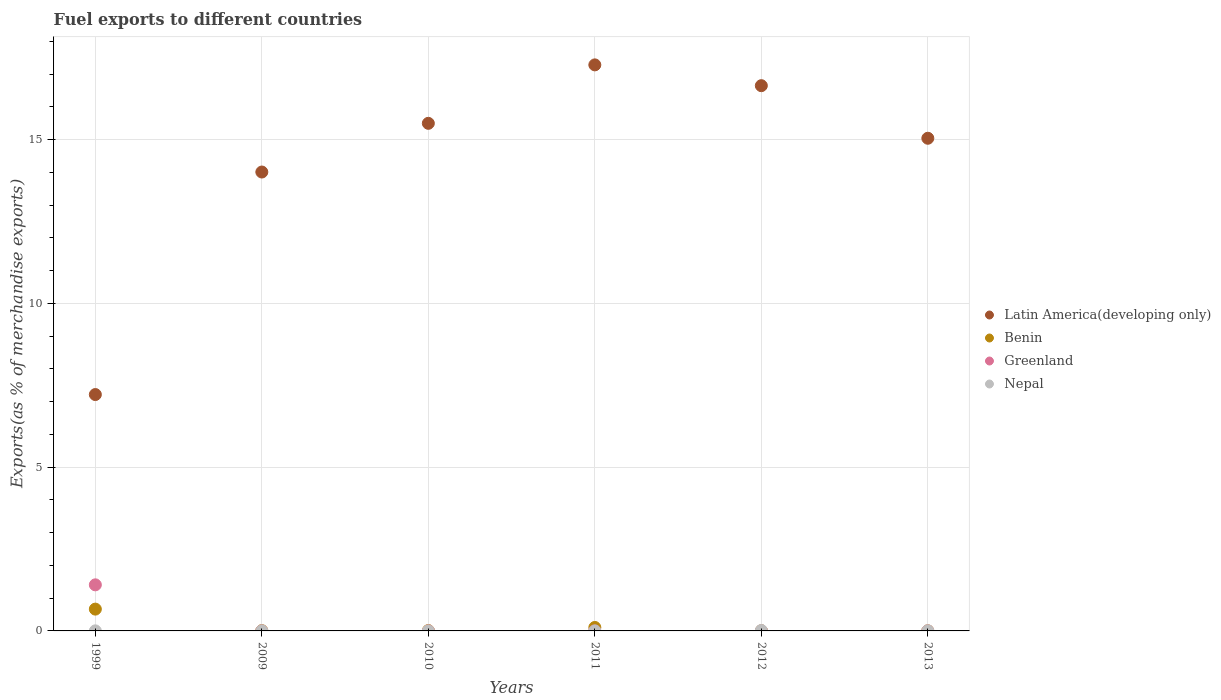Is the number of dotlines equal to the number of legend labels?
Keep it short and to the point. Yes. What is the percentage of exports to different countries in Benin in 1999?
Your answer should be very brief. 0.67. Across all years, what is the maximum percentage of exports to different countries in Nepal?
Offer a very short reply. 0.01. Across all years, what is the minimum percentage of exports to different countries in Nepal?
Give a very brief answer. 5.17830048737702e-6. In which year was the percentage of exports to different countries in Greenland minimum?
Keep it short and to the point. 2009. What is the total percentage of exports to different countries in Nepal in the graph?
Offer a terse response. 0.02. What is the difference between the percentage of exports to different countries in Greenland in 2009 and that in 2013?
Make the answer very short. -1.022851783200839e-5. What is the difference between the percentage of exports to different countries in Greenland in 2011 and the percentage of exports to different countries in Benin in 1999?
Your answer should be very brief. -0.67. What is the average percentage of exports to different countries in Benin per year?
Offer a terse response. 0.13. In the year 2009, what is the difference between the percentage of exports to different countries in Latin America(developing only) and percentage of exports to different countries in Benin?
Keep it short and to the point. 14. In how many years, is the percentage of exports to different countries in Latin America(developing only) greater than 7 %?
Offer a very short reply. 6. What is the ratio of the percentage of exports to different countries in Greenland in 2010 to that in 2013?
Provide a short and direct response. 6.64. Is the difference between the percentage of exports to different countries in Latin America(developing only) in 1999 and 2011 greater than the difference between the percentage of exports to different countries in Benin in 1999 and 2011?
Provide a short and direct response. No. What is the difference between the highest and the second highest percentage of exports to different countries in Greenland?
Provide a succinct answer. 1.41. What is the difference between the highest and the lowest percentage of exports to different countries in Greenland?
Give a very brief answer. 1.41. Is the sum of the percentage of exports to different countries in Nepal in 2009 and 2011 greater than the maximum percentage of exports to different countries in Benin across all years?
Offer a terse response. No. Is it the case that in every year, the sum of the percentage of exports to different countries in Greenland and percentage of exports to different countries in Latin America(developing only)  is greater than the sum of percentage of exports to different countries in Nepal and percentage of exports to different countries in Benin?
Your answer should be compact. Yes. Does the percentage of exports to different countries in Benin monotonically increase over the years?
Your response must be concise. No. What is the title of the graph?
Give a very brief answer. Fuel exports to different countries. Does "Brunei Darussalam" appear as one of the legend labels in the graph?
Your answer should be compact. No. What is the label or title of the X-axis?
Ensure brevity in your answer.  Years. What is the label or title of the Y-axis?
Provide a succinct answer. Exports(as % of merchandise exports). What is the Exports(as % of merchandise exports) in Latin America(developing only) in 1999?
Ensure brevity in your answer.  7.22. What is the Exports(as % of merchandise exports) of Benin in 1999?
Provide a succinct answer. 0.67. What is the Exports(as % of merchandise exports) in Greenland in 1999?
Your answer should be compact. 1.41. What is the Exports(as % of merchandise exports) in Nepal in 1999?
Ensure brevity in your answer.  0. What is the Exports(as % of merchandise exports) in Latin America(developing only) in 2009?
Make the answer very short. 14.01. What is the Exports(as % of merchandise exports) of Benin in 2009?
Provide a short and direct response. 0.01. What is the Exports(as % of merchandise exports) of Greenland in 2009?
Ensure brevity in your answer.  6.028633814473571e-5. What is the Exports(as % of merchandise exports) of Nepal in 2009?
Offer a very short reply. 0. What is the Exports(as % of merchandise exports) of Latin America(developing only) in 2010?
Offer a terse response. 15.5. What is the Exports(as % of merchandise exports) in Benin in 2010?
Give a very brief answer. 0.01. What is the Exports(as % of merchandise exports) in Greenland in 2010?
Offer a very short reply. 0. What is the Exports(as % of merchandise exports) in Nepal in 2010?
Offer a terse response. 4.5184108995034e-5. What is the Exports(as % of merchandise exports) in Latin America(developing only) in 2011?
Ensure brevity in your answer.  17.28. What is the Exports(as % of merchandise exports) in Benin in 2011?
Make the answer very short. 0.11. What is the Exports(as % of merchandise exports) of Greenland in 2011?
Offer a very short reply. 0. What is the Exports(as % of merchandise exports) in Nepal in 2011?
Give a very brief answer. 5.17830048737702e-6. What is the Exports(as % of merchandise exports) in Latin America(developing only) in 2012?
Your answer should be compact. 16.65. What is the Exports(as % of merchandise exports) of Benin in 2012?
Offer a terse response. 0.01. What is the Exports(as % of merchandise exports) in Greenland in 2012?
Give a very brief answer. 0. What is the Exports(as % of merchandise exports) of Nepal in 2012?
Give a very brief answer. 0.01. What is the Exports(as % of merchandise exports) in Latin America(developing only) in 2013?
Your response must be concise. 15.04. What is the Exports(as % of merchandise exports) of Benin in 2013?
Your answer should be very brief. 0. What is the Exports(as % of merchandise exports) in Greenland in 2013?
Your answer should be very brief. 7.05148559767441e-5. What is the Exports(as % of merchandise exports) in Nepal in 2013?
Make the answer very short. 0. Across all years, what is the maximum Exports(as % of merchandise exports) in Latin America(developing only)?
Ensure brevity in your answer.  17.28. Across all years, what is the maximum Exports(as % of merchandise exports) in Benin?
Your response must be concise. 0.67. Across all years, what is the maximum Exports(as % of merchandise exports) in Greenland?
Ensure brevity in your answer.  1.41. Across all years, what is the maximum Exports(as % of merchandise exports) in Nepal?
Provide a succinct answer. 0.01. Across all years, what is the minimum Exports(as % of merchandise exports) in Latin America(developing only)?
Your response must be concise. 7.22. Across all years, what is the minimum Exports(as % of merchandise exports) in Benin?
Your response must be concise. 0. Across all years, what is the minimum Exports(as % of merchandise exports) in Greenland?
Ensure brevity in your answer.  6.028633814473571e-5. Across all years, what is the minimum Exports(as % of merchandise exports) in Nepal?
Ensure brevity in your answer.  5.17830048737702e-6. What is the total Exports(as % of merchandise exports) of Latin America(developing only) in the graph?
Make the answer very short. 85.71. What is the total Exports(as % of merchandise exports) of Benin in the graph?
Offer a terse response. 0.8. What is the total Exports(as % of merchandise exports) of Greenland in the graph?
Your answer should be compact. 1.41. What is the total Exports(as % of merchandise exports) of Nepal in the graph?
Ensure brevity in your answer.  0.02. What is the difference between the Exports(as % of merchandise exports) in Latin America(developing only) in 1999 and that in 2009?
Your answer should be compact. -6.79. What is the difference between the Exports(as % of merchandise exports) of Benin in 1999 and that in 2009?
Offer a terse response. 0.66. What is the difference between the Exports(as % of merchandise exports) of Greenland in 1999 and that in 2009?
Ensure brevity in your answer.  1.41. What is the difference between the Exports(as % of merchandise exports) of Latin America(developing only) in 1999 and that in 2010?
Ensure brevity in your answer.  -8.28. What is the difference between the Exports(as % of merchandise exports) in Benin in 1999 and that in 2010?
Make the answer very short. 0.66. What is the difference between the Exports(as % of merchandise exports) in Greenland in 1999 and that in 2010?
Give a very brief answer. 1.41. What is the difference between the Exports(as % of merchandise exports) of Nepal in 1999 and that in 2010?
Provide a short and direct response. 0. What is the difference between the Exports(as % of merchandise exports) in Latin America(developing only) in 1999 and that in 2011?
Offer a terse response. -10.07. What is the difference between the Exports(as % of merchandise exports) in Benin in 1999 and that in 2011?
Keep it short and to the point. 0.56. What is the difference between the Exports(as % of merchandise exports) of Greenland in 1999 and that in 2011?
Ensure brevity in your answer.  1.41. What is the difference between the Exports(as % of merchandise exports) of Nepal in 1999 and that in 2011?
Offer a very short reply. 0. What is the difference between the Exports(as % of merchandise exports) in Latin America(developing only) in 1999 and that in 2012?
Your answer should be very brief. -9.43. What is the difference between the Exports(as % of merchandise exports) in Benin in 1999 and that in 2012?
Keep it short and to the point. 0.66. What is the difference between the Exports(as % of merchandise exports) in Greenland in 1999 and that in 2012?
Your answer should be very brief. 1.41. What is the difference between the Exports(as % of merchandise exports) of Nepal in 1999 and that in 2012?
Ensure brevity in your answer.  -0.01. What is the difference between the Exports(as % of merchandise exports) of Latin America(developing only) in 1999 and that in 2013?
Provide a short and direct response. -7.83. What is the difference between the Exports(as % of merchandise exports) of Benin in 1999 and that in 2013?
Give a very brief answer. 0.66. What is the difference between the Exports(as % of merchandise exports) of Greenland in 1999 and that in 2013?
Your response must be concise. 1.41. What is the difference between the Exports(as % of merchandise exports) of Nepal in 1999 and that in 2013?
Keep it short and to the point. -0. What is the difference between the Exports(as % of merchandise exports) of Latin America(developing only) in 2009 and that in 2010?
Provide a succinct answer. -1.49. What is the difference between the Exports(as % of merchandise exports) of Benin in 2009 and that in 2010?
Give a very brief answer. -0. What is the difference between the Exports(as % of merchandise exports) in Greenland in 2009 and that in 2010?
Give a very brief answer. -0. What is the difference between the Exports(as % of merchandise exports) of Nepal in 2009 and that in 2010?
Your answer should be very brief. 0. What is the difference between the Exports(as % of merchandise exports) in Latin America(developing only) in 2009 and that in 2011?
Provide a succinct answer. -3.27. What is the difference between the Exports(as % of merchandise exports) in Benin in 2009 and that in 2011?
Provide a succinct answer. -0.1. What is the difference between the Exports(as % of merchandise exports) of Greenland in 2009 and that in 2011?
Your answer should be compact. -0. What is the difference between the Exports(as % of merchandise exports) in Nepal in 2009 and that in 2011?
Your answer should be very brief. 0. What is the difference between the Exports(as % of merchandise exports) in Latin America(developing only) in 2009 and that in 2012?
Provide a short and direct response. -2.64. What is the difference between the Exports(as % of merchandise exports) of Benin in 2009 and that in 2012?
Offer a very short reply. 0. What is the difference between the Exports(as % of merchandise exports) of Greenland in 2009 and that in 2012?
Give a very brief answer. -0. What is the difference between the Exports(as % of merchandise exports) in Nepal in 2009 and that in 2012?
Offer a very short reply. -0.01. What is the difference between the Exports(as % of merchandise exports) in Latin America(developing only) in 2009 and that in 2013?
Your response must be concise. -1.03. What is the difference between the Exports(as % of merchandise exports) of Benin in 2009 and that in 2013?
Ensure brevity in your answer.  0.01. What is the difference between the Exports(as % of merchandise exports) in Greenland in 2009 and that in 2013?
Keep it short and to the point. -0. What is the difference between the Exports(as % of merchandise exports) of Nepal in 2009 and that in 2013?
Provide a short and direct response. -0. What is the difference between the Exports(as % of merchandise exports) in Latin America(developing only) in 2010 and that in 2011?
Ensure brevity in your answer.  -1.78. What is the difference between the Exports(as % of merchandise exports) in Benin in 2010 and that in 2011?
Make the answer very short. -0.09. What is the difference between the Exports(as % of merchandise exports) of Greenland in 2010 and that in 2011?
Ensure brevity in your answer.  0. What is the difference between the Exports(as % of merchandise exports) of Latin America(developing only) in 2010 and that in 2012?
Your answer should be very brief. -1.15. What is the difference between the Exports(as % of merchandise exports) in Benin in 2010 and that in 2012?
Your answer should be compact. 0.01. What is the difference between the Exports(as % of merchandise exports) in Greenland in 2010 and that in 2012?
Offer a very short reply. 0. What is the difference between the Exports(as % of merchandise exports) of Nepal in 2010 and that in 2012?
Your answer should be compact. -0.01. What is the difference between the Exports(as % of merchandise exports) in Latin America(developing only) in 2010 and that in 2013?
Your answer should be compact. 0.46. What is the difference between the Exports(as % of merchandise exports) of Benin in 2010 and that in 2013?
Ensure brevity in your answer.  0.01. What is the difference between the Exports(as % of merchandise exports) of Nepal in 2010 and that in 2013?
Ensure brevity in your answer.  -0. What is the difference between the Exports(as % of merchandise exports) of Latin America(developing only) in 2011 and that in 2012?
Offer a terse response. 0.64. What is the difference between the Exports(as % of merchandise exports) of Benin in 2011 and that in 2012?
Offer a very short reply. 0.1. What is the difference between the Exports(as % of merchandise exports) in Nepal in 2011 and that in 2012?
Your answer should be very brief. -0.01. What is the difference between the Exports(as % of merchandise exports) of Latin America(developing only) in 2011 and that in 2013?
Keep it short and to the point. 2.24. What is the difference between the Exports(as % of merchandise exports) in Benin in 2011 and that in 2013?
Your answer should be compact. 0.1. What is the difference between the Exports(as % of merchandise exports) in Nepal in 2011 and that in 2013?
Give a very brief answer. -0. What is the difference between the Exports(as % of merchandise exports) of Latin America(developing only) in 2012 and that in 2013?
Offer a very short reply. 1.61. What is the difference between the Exports(as % of merchandise exports) in Benin in 2012 and that in 2013?
Your answer should be compact. 0. What is the difference between the Exports(as % of merchandise exports) in Greenland in 2012 and that in 2013?
Provide a short and direct response. 0. What is the difference between the Exports(as % of merchandise exports) of Nepal in 2012 and that in 2013?
Provide a short and direct response. 0.01. What is the difference between the Exports(as % of merchandise exports) of Latin America(developing only) in 1999 and the Exports(as % of merchandise exports) of Benin in 2009?
Keep it short and to the point. 7.21. What is the difference between the Exports(as % of merchandise exports) of Latin America(developing only) in 1999 and the Exports(as % of merchandise exports) of Greenland in 2009?
Provide a succinct answer. 7.22. What is the difference between the Exports(as % of merchandise exports) in Latin America(developing only) in 1999 and the Exports(as % of merchandise exports) in Nepal in 2009?
Make the answer very short. 7.22. What is the difference between the Exports(as % of merchandise exports) in Benin in 1999 and the Exports(as % of merchandise exports) in Greenland in 2009?
Keep it short and to the point. 0.67. What is the difference between the Exports(as % of merchandise exports) of Benin in 1999 and the Exports(as % of merchandise exports) of Nepal in 2009?
Offer a very short reply. 0.66. What is the difference between the Exports(as % of merchandise exports) of Greenland in 1999 and the Exports(as % of merchandise exports) of Nepal in 2009?
Make the answer very short. 1.41. What is the difference between the Exports(as % of merchandise exports) in Latin America(developing only) in 1999 and the Exports(as % of merchandise exports) in Benin in 2010?
Your response must be concise. 7.21. What is the difference between the Exports(as % of merchandise exports) in Latin America(developing only) in 1999 and the Exports(as % of merchandise exports) in Greenland in 2010?
Give a very brief answer. 7.22. What is the difference between the Exports(as % of merchandise exports) of Latin America(developing only) in 1999 and the Exports(as % of merchandise exports) of Nepal in 2010?
Give a very brief answer. 7.22. What is the difference between the Exports(as % of merchandise exports) of Benin in 1999 and the Exports(as % of merchandise exports) of Greenland in 2010?
Offer a terse response. 0.67. What is the difference between the Exports(as % of merchandise exports) of Benin in 1999 and the Exports(as % of merchandise exports) of Nepal in 2010?
Your response must be concise. 0.67. What is the difference between the Exports(as % of merchandise exports) in Greenland in 1999 and the Exports(as % of merchandise exports) in Nepal in 2010?
Your response must be concise. 1.41. What is the difference between the Exports(as % of merchandise exports) in Latin America(developing only) in 1999 and the Exports(as % of merchandise exports) in Benin in 2011?
Offer a terse response. 7.11. What is the difference between the Exports(as % of merchandise exports) in Latin America(developing only) in 1999 and the Exports(as % of merchandise exports) in Greenland in 2011?
Provide a succinct answer. 7.22. What is the difference between the Exports(as % of merchandise exports) of Latin America(developing only) in 1999 and the Exports(as % of merchandise exports) of Nepal in 2011?
Offer a very short reply. 7.22. What is the difference between the Exports(as % of merchandise exports) of Benin in 1999 and the Exports(as % of merchandise exports) of Greenland in 2011?
Provide a short and direct response. 0.67. What is the difference between the Exports(as % of merchandise exports) of Benin in 1999 and the Exports(as % of merchandise exports) of Nepal in 2011?
Give a very brief answer. 0.67. What is the difference between the Exports(as % of merchandise exports) in Greenland in 1999 and the Exports(as % of merchandise exports) in Nepal in 2011?
Provide a short and direct response. 1.41. What is the difference between the Exports(as % of merchandise exports) of Latin America(developing only) in 1999 and the Exports(as % of merchandise exports) of Benin in 2012?
Your response must be concise. 7.21. What is the difference between the Exports(as % of merchandise exports) of Latin America(developing only) in 1999 and the Exports(as % of merchandise exports) of Greenland in 2012?
Your response must be concise. 7.22. What is the difference between the Exports(as % of merchandise exports) in Latin America(developing only) in 1999 and the Exports(as % of merchandise exports) in Nepal in 2012?
Your response must be concise. 7.2. What is the difference between the Exports(as % of merchandise exports) of Benin in 1999 and the Exports(as % of merchandise exports) of Greenland in 2012?
Make the answer very short. 0.67. What is the difference between the Exports(as % of merchandise exports) in Benin in 1999 and the Exports(as % of merchandise exports) in Nepal in 2012?
Your answer should be very brief. 0.65. What is the difference between the Exports(as % of merchandise exports) in Greenland in 1999 and the Exports(as % of merchandise exports) in Nepal in 2012?
Ensure brevity in your answer.  1.39. What is the difference between the Exports(as % of merchandise exports) of Latin America(developing only) in 1999 and the Exports(as % of merchandise exports) of Benin in 2013?
Offer a terse response. 7.22. What is the difference between the Exports(as % of merchandise exports) in Latin America(developing only) in 1999 and the Exports(as % of merchandise exports) in Greenland in 2013?
Provide a succinct answer. 7.22. What is the difference between the Exports(as % of merchandise exports) of Latin America(developing only) in 1999 and the Exports(as % of merchandise exports) of Nepal in 2013?
Your response must be concise. 7.21. What is the difference between the Exports(as % of merchandise exports) in Benin in 1999 and the Exports(as % of merchandise exports) in Greenland in 2013?
Make the answer very short. 0.67. What is the difference between the Exports(as % of merchandise exports) in Benin in 1999 and the Exports(as % of merchandise exports) in Nepal in 2013?
Provide a succinct answer. 0.66. What is the difference between the Exports(as % of merchandise exports) in Greenland in 1999 and the Exports(as % of merchandise exports) in Nepal in 2013?
Keep it short and to the point. 1.4. What is the difference between the Exports(as % of merchandise exports) of Latin America(developing only) in 2009 and the Exports(as % of merchandise exports) of Benin in 2010?
Your answer should be very brief. 14. What is the difference between the Exports(as % of merchandise exports) in Latin America(developing only) in 2009 and the Exports(as % of merchandise exports) in Greenland in 2010?
Your answer should be very brief. 14.01. What is the difference between the Exports(as % of merchandise exports) of Latin America(developing only) in 2009 and the Exports(as % of merchandise exports) of Nepal in 2010?
Keep it short and to the point. 14.01. What is the difference between the Exports(as % of merchandise exports) in Benin in 2009 and the Exports(as % of merchandise exports) in Greenland in 2010?
Your answer should be very brief. 0.01. What is the difference between the Exports(as % of merchandise exports) in Benin in 2009 and the Exports(as % of merchandise exports) in Nepal in 2010?
Give a very brief answer. 0.01. What is the difference between the Exports(as % of merchandise exports) of Greenland in 2009 and the Exports(as % of merchandise exports) of Nepal in 2010?
Give a very brief answer. 0. What is the difference between the Exports(as % of merchandise exports) of Latin America(developing only) in 2009 and the Exports(as % of merchandise exports) of Benin in 2011?
Your response must be concise. 13.91. What is the difference between the Exports(as % of merchandise exports) in Latin America(developing only) in 2009 and the Exports(as % of merchandise exports) in Greenland in 2011?
Provide a short and direct response. 14.01. What is the difference between the Exports(as % of merchandise exports) in Latin America(developing only) in 2009 and the Exports(as % of merchandise exports) in Nepal in 2011?
Provide a short and direct response. 14.01. What is the difference between the Exports(as % of merchandise exports) of Benin in 2009 and the Exports(as % of merchandise exports) of Greenland in 2011?
Keep it short and to the point. 0.01. What is the difference between the Exports(as % of merchandise exports) of Benin in 2009 and the Exports(as % of merchandise exports) of Nepal in 2011?
Provide a short and direct response. 0.01. What is the difference between the Exports(as % of merchandise exports) in Latin America(developing only) in 2009 and the Exports(as % of merchandise exports) in Benin in 2012?
Your answer should be very brief. 14.01. What is the difference between the Exports(as % of merchandise exports) of Latin America(developing only) in 2009 and the Exports(as % of merchandise exports) of Greenland in 2012?
Provide a succinct answer. 14.01. What is the difference between the Exports(as % of merchandise exports) in Latin America(developing only) in 2009 and the Exports(as % of merchandise exports) in Nepal in 2012?
Your answer should be compact. 14. What is the difference between the Exports(as % of merchandise exports) of Benin in 2009 and the Exports(as % of merchandise exports) of Greenland in 2012?
Keep it short and to the point. 0.01. What is the difference between the Exports(as % of merchandise exports) in Benin in 2009 and the Exports(as % of merchandise exports) in Nepal in 2012?
Your answer should be compact. -0. What is the difference between the Exports(as % of merchandise exports) in Greenland in 2009 and the Exports(as % of merchandise exports) in Nepal in 2012?
Keep it short and to the point. -0.01. What is the difference between the Exports(as % of merchandise exports) in Latin America(developing only) in 2009 and the Exports(as % of merchandise exports) in Benin in 2013?
Ensure brevity in your answer.  14.01. What is the difference between the Exports(as % of merchandise exports) of Latin America(developing only) in 2009 and the Exports(as % of merchandise exports) of Greenland in 2013?
Your response must be concise. 14.01. What is the difference between the Exports(as % of merchandise exports) of Latin America(developing only) in 2009 and the Exports(as % of merchandise exports) of Nepal in 2013?
Make the answer very short. 14.01. What is the difference between the Exports(as % of merchandise exports) of Benin in 2009 and the Exports(as % of merchandise exports) of Greenland in 2013?
Make the answer very short. 0.01. What is the difference between the Exports(as % of merchandise exports) of Benin in 2009 and the Exports(as % of merchandise exports) of Nepal in 2013?
Ensure brevity in your answer.  0. What is the difference between the Exports(as % of merchandise exports) of Greenland in 2009 and the Exports(as % of merchandise exports) of Nepal in 2013?
Provide a succinct answer. -0. What is the difference between the Exports(as % of merchandise exports) in Latin America(developing only) in 2010 and the Exports(as % of merchandise exports) in Benin in 2011?
Offer a terse response. 15.39. What is the difference between the Exports(as % of merchandise exports) of Latin America(developing only) in 2010 and the Exports(as % of merchandise exports) of Greenland in 2011?
Your response must be concise. 15.5. What is the difference between the Exports(as % of merchandise exports) in Latin America(developing only) in 2010 and the Exports(as % of merchandise exports) in Nepal in 2011?
Keep it short and to the point. 15.5. What is the difference between the Exports(as % of merchandise exports) of Benin in 2010 and the Exports(as % of merchandise exports) of Greenland in 2011?
Your answer should be compact. 0.01. What is the difference between the Exports(as % of merchandise exports) in Benin in 2010 and the Exports(as % of merchandise exports) in Nepal in 2011?
Your answer should be very brief. 0.01. What is the difference between the Exports(as % of merchandise exports) of Greenland in 2010 and the Exports(as % of merchandise exports) of Nepal in 2011?
Keep it short and to the point. 0. What is the difference between the Exports(as % of merchandise exports) of Latin America(developing only) in 2010 and the Exports(as % of merchandise exports) of Benin in 2012?
Provide a short and direct response. 15.49. What is the difference between the Exports(as % of merchandise exports) in Latin America(developing only) in 2010 and the Exports(as % of merchandise exports) in Greenland in 2012?
Your answer should be very brief. 15.5. What is the difference between the Exports(as % of merchandise exports) of Latin America(developing only) in 2010 and the Exports(as % of merchandise exports) of Nepal in 2012?
Offer a very short reply. 15.49. What is the difference between the Exports(as % of merchandise exports) in Benin in 2010 and the Exports(as % of merchandise exports) in Greenland in 2012?
Keep it short and to the point. 0.01. What is the difference between the Exports(as % of merchandise exports) in Benin in 2010 and the Exports(as % of merchandise exports) in Nepal in 2012?
Give a very brief answer. -0. What is the difference between the Exports(as % of merchandise exports) of Greenland in 2010 and the Exports(as % of merchandise exports) of Nepal in 2012?
Provide a succinct answer. -0.01. What is the difference between the Exports(as % of merchandise exports) of Latin America(developing only) in 2010 and the Exports(as % of merchandise exports) of Benin in 2013?
Give a very brief answer. 15.5. What is the difference between the Exports(as % of merchandise exports) in Latin America(developing only) in 2010 and the Exports(as % of merchandise exports) in Greenland in 2013?
Make the answer very short. 15.5. What is the difference between the Exports(as % of merchandise exports) in Latin America(developing only) in 2010 and the Exports(as % of merchandise exports) in Nepal in 2013?
Make the answer very short. 15.5. What is the difference between the Exports(as % of merchandise exports) in Benin in 2010 and the Exports(as % of merchandise exports) in Greenland in 2013?
Keep it short and to the point. 0.01. What is the difference between the Exports(as % of merchandise exports) in Benin in 2010 and the Exports(as % of merchandise exports) in Nepal in 2013?
Make the answer very short. 0.01. What is the difference between the Exports(as % of merchandise exports) of Greenland in 2010 and the Exports(as % of merchandise exports) of Nepal in 2013?
Your response must be concise. -0. What is the difference between the Exports(as % of merchandise exports) in Latin America(developing only) in 2011 and the Exports(as % of merchandise exports) in Benin in 2012?
Your answer should be very brief. 17.28. What is the difference between the Exports(as % of merchandise exports) of Latin America(developing only) in 2011 and the Exports(as % of merchandise exports) of Greenland in 2012?
Your answer should be very brief. 17.28. What is the difference between the Exports(as % of merchandise exports) in Latin America(developing only) in 2011 and the Exports(as % of merchandise exports) in Nepal in 2012?
Ensure brevity in your answer.  17.27. What is the difference between the Exports(as % of merchandise exports) in Benin in 2011 and the Exports(as % of merchandise exports) in Greenland in 2012?
Ensure brevity in your answer.  0.11. What is the difference between the Exports(as % of merchandise exports) of Benin in 2011 and the Exports(as % of merchandise exports) of Nepal in 2012?
Your response must be concise. 0.09. What is the difference between the Exports(as % of merchandise exports) in Greenland in 2011 and the Exports(as % of merchandise exports) in Nepal in 2012?
Give a very brief answer. -0.01. What is the difference between the Exports(as % of merchandise exports) in Latin America(developing only) in 2011 and the Exports(as % of merchandise exports) in Benin in 2013?
Offer a very short reply. 17.28. What is the difference between the Exports(as % of merchandise exports) in Latin America(developing only) in 2011 and the Exports(as % of merchandise exports) in Greenland in 2013?
Keep it short and to the point. 17.28. What is the difference between the Exports(as % of merchandise exports) of Latin America(developing only) in 2011 and the Exports(as % of merchandise exports) of Nepal in 2013?
Offer a terse response. 17.28. What is the difference between the Exports(as % of merchandise exports) in Benin in 2011 and the Exports(as % of merchandise exports) in Greenland in 2013?
Your response must be concise. 0.11. What is the difference between the Exports(as % of merchandise exports) of Benin in 2011 and the Exports(as % of merchandise exports) of Nepal in 2013?
Provide a succinct answer. 0.1. What is the difference between the Exports(as % of merchandise exports) of Greenland in 2011 and the Exports(as % of merchandise exports) of Nepal in 2013?
Ensure brevity in your answer.  -0. What is the difference between the Exports(as % of merchandise exports) in Latin America(developing only) in 2012 and the Exports(as % of merchandise exports) in Benin in 2013?
Your answer should be compact. 16.65. What is the difference between the Exports(as % of merchandise exports) in Latin America(developing only) in 2012 and the Exports(as % of merchandise exports) in Greenland in 2013?
Keep it short and to the point. 16.65. What is the difference between the Exports(as % of merchandise exports) of Latin America(developing only) in 2012 and the Exports(as % of merchandise exports) of Nepal in 2013?
Provide a short and direct response. 16.65. What is the difference between the Exports(as % of merchandise exports) in Benin in 2012 and the Exports(as % of merchandise exports) in Greenland in 2013?
Offer a very short reply. 0.01. What is the difference between the Exports(as % of merchandise exports) of Benin in 2012 and the Exports(as % of merchandise exports) of Nepal in 2013?
Make the answer very short. 0. What is the difference between the Exports(as % of merchandise exports) in Greenland in 2012 and the Exports(as % of merchandise exports) in Nepal in 2013?
Your response must be concise. -0. What is the average Exports(as % of merchandise exports) of Latin America(developing only) per year?
Your response must be concise. 14.28. What is the average Exports(as % of merchandise exports) in Benin per year?
Provide a succinct answer. 0.13. What is the average Exports(as % of merchandise exports) of Greenland per year?
Your answer should be compact. 0.23. What is the average Exports(as % of merchandise exports) of Nepal per year?
Your response must be concise. 0. In the year 1999, what is the difference between the Exports(as % of merchandise exports) in Latin America(developing only) and Exports(as % of merchandise exports) in Benin?
Ensure brevity in your answer.  6.55. In the year 1999, what is the difference between the Exports(as % of merchandise exports) of Latin America(developing only) and Exports(as % of merchandise exports) of Greenland?
Give a very brief answer. 5.81. In the year 1999, what is the difference between the Exports(as % of merchandise exports) of Latin America(developing only) and Exports(as % of merchandise exports) of Nepal?
Your answer should be compact. 7.22. In the year 1999, what is the difference between the Exports(as % of merchandise exports) of Benin and Exports(as % of merchandise exports) of Greenland?
Provide a short and direct response. -0.74. In the year 1999, what is the difference between the Exports(as % of merchandise exports) of Benin and Exports(as % of merchandise exports) of Nepal?
Keep it short and to the point. 0.66. In the year 1999, what is the difference between the Exports(as % of merchandise exports) in Greenland and Exports(as % of merchandise exports) in Nepal?
Provide a short and direct response. 1.41. In the year 2009, what is the difference between the Exports(as % of merchandise exports) of Latin America(developing only) and Exports(as % of merchandise exports) of Benin?
Your answer should be very brief. 14. In the year 2009, what is the difference between the Exports(as % of merchandise exports) in Latin America(developing only) and Exports(as % of merchandise exports) in Greenland?
Your answer should be very brief. 14.01. In the year 2009, what is the difference between the Exports(as % of merchandise exports) of Latin America(developing only) and Exports(as % of merchandise exports) of Nepal?
Make the answer very short. 14.01. In the year 2009, what is the difference between the Exports(as % of merchandise exports) of Benin and Exports(as % of merchandise exports) of Greenland?
Provide a short and direct response. 0.01. In the year 2009, what is the difference between the Exports(as % of merchandise exports) of Benin and Exports(as % of merchandise exports) of Nepal?
Your answer should be very brief. 0.01. In the year 2009, what is the difference between the Exports(as % of merchandise exports) of Greenland and Exports(as % of merchandise exports) of Nepal?
Your answer should be very brief. -0. In the year 2010, what is the difference between the Exports(as % of merchandise exports) in Latin America(developing only) and Exports(as % of merchandise exports) in Benin?
Provide a short and direct response. 15.49. In the year 2010, what is the difference between the Exports(as % of merchandise exports) in Latin America(developing only) and Exports(as % of merchandise exports) in Greenland?
Give a very brief answer. 15.5. In the year 2010, what is the difference between the Exports(as % of merchandise exports) in Latin America(developing only) and Exports(as % of merchandise exports) in Nepal?
Keep it short and to the point. 15.5. In the year 2010, what is the difference between the Exports(as % of merchandise exports) in Benin and Exports(as % of merchandise exports) in Greenland?
Offer a terse response. 0.01. In the year 2010, what is the difference between the Exports(as % of merchandise exports) of Benin and Exports(as % of merchandise exports) of Nepal?
Your answer should be compact. 0.01. In the year 2011, what is the difference between the Exports(as % of merchandise exports) of Latin America(developing only) and Exports(as % of merchandise exports) of Benin?
Keep it short and to the point. 17.18. In the year 2011, what is the difference between the Exports(as % of merchandise exports) of Latin America(developing only) and Exports(as % of merchandise exports) of Greenland?
Keep it short and to the point. 17.28. In the year 2011, what is the difference between the Exports(as % of merchandise exports) in Latin America(developing only) and Exports(as % of merchandise exports) in Nepal?
Ensure brevity in your answer.  17.28. In the year 2011, what is the difference between the Exports(as % of merchandise exports) in Benin and Exports(as % of merchandise exports) in Greenland?
Keep it short and to the point. 0.11. In the year 2011, what is the difference between the Exports(as % of merchandise exports) in Benin and Exports(as % of merchandise exports) in Nepal?
Ensure brevity in your answer.  0.11. In the year 2011, what is the difference between the Exports(as % of merchandise exports) in Greenland and Exports(as % of merchandise exports) in Nepal?
Your answer should be very brief. 0. In the year 2012, what is the difference between the Exports(as % of merchandise exports) of Latin America(developing only) and Exports(as % of merchandise exports) of Benin?
Your response must be concise. 16.64. In the year 2012, what is the difference between the Exports(as % of merchandise exports) in Latin America(developing only) and Exports(as % of merchandise exports) in Greenland?
Offer a very short reply. 16.65. In the year 2012, what is the difference between the Exports(as % of merchandise exports) of Latin America(developing only) and Exports(as % of merchandise exports) of Nepal?
Provide a short and direct response. 16.64. In the year 2012, what is the difference between the Exports(as % of merchandise exports) of Benin and Exports(as % of merchandise exports) of Greenland?
Ensure brevity in your answer.  0.01. In the year 2012, what is the difference between the Exports(as % of merchandise exports) of Benin and Exports(as % of merchandise exports) of Nepal?
Provide a short and direct response. -0.01. In the year 2012, what is the difference between the Exports(as % of merchandise exports) of Greenland and Exports(as % of merchandise exports) of Nepal?
Give a very brief answer. -0.01. In the year 2013, what is the difference between the Exports(as % of merchandise exports) of Latin America(developing only) and Exports(as % of merchandise exports) of Benin?
Provide a short and direct response. 15.04. In the year 2013, what is the difference between the Exports(as % of merchandise exports) in Latin America(developing only) and Exports(as % of merchandise exports) in Greenland?
Your answer should be very brief. 15.04. In the year 2013, what is the difference between the Exports(as % of merchandise exports) of Latin America(developing only) and Exports(as % of merchandise exports) of Nepal?
Ensure brevity in your answer.  15.04. In the year 2013, what is the difference between the Exports(as % of merchandise exports) in Benin and Exports(as % of merchandise exports) in Greenland?
Your answer should be compact. 0. In the year 2013, what is the difference between the Exports(as % of merchandise exports) of Benin and Exports(as % of merchandise exports) of Nepal?
Offer a very short reply. -0. In the year 2013, what is the difference between the Exports(as % of merchandise exports) in Greenland and Exports(as % of merchandise exports) in Nepal?
Your answer should be compact. -0. What is the ratio of the Exports(as % of merchandise exports) in Latin America(developing only) in 1999 to that in 2009?
Ensure brevity in your answer.  0.52. What is the ratio of the Exports(as % of merchandise exports) in Benin in 1999 to that in 2009?
Give a very brief answer. 83.44. What is the ratio of the Exports(as % of merchandise exports) of Greenland in 1999 to that in 2009?
Provide a short and direct response. 2.33e+04. What is the ratio of the Exports(as % of merchandise exports) of Nepal in 1999 to that in 2009?
Provide a succinct answer. 1.28. What is the ratio of the Exports(as % of merchandise exports) of Latin America(developing only) in 1999 to that in 2010?
Offer a very short reply. 0.47. What is the ratio of the Exports(as % of merchandise exports) in Benin in 1999 to that in 2010?
Provide a short and direct response. 62.06. What is the ratio of the Exports(as % of merchandise exports) in Greenland in 1999 to that in 2010?
Provide a succinct answer. 3007.28. What is the ratio of the Exports(as % of merchandise exports) of Nepal in 1999 to that in 2010?
Ensure brevity in your answer.  47.85. What is the ratio of the Exports(as % of merchandise exports) in Latin America(developing only) in 1999 to that in 2011?
Keep it short and to the point. 0.42. What is the ratio of the Exports(as % of merchandise exports) in Benin in 1999 to that in 2011?
Keep it short and to the point. 6.31. What is the ratio of the Exports(as % of merchandise exports) of Greenland in 1999 to that in 2011?
Provide a short and direct response. 5542.4. What is the ratio of the Exports(as % of merchandise exports) in Nepal in 1999 to that in 2011?
Your response must be concise. 417.54. What is the ratio of the Exports(as % of merchandise exports) of Latin America(developing only) in 1999 to that in 2012?
Offer a very short reply. 0.43. What is the ratio of the Exports(as % of merchandise exports) of Benin in 1999 to that in 2012?
Ensure brevity in your answer.  130.07. What is the ratio of the Exports(as % of merchandise exports) in Greenland in 1999 to that in 2012?
Make the answer very short. 1.13e+04. What is the ratio of the Exports(as % of merchandise exports) in Nepal in 1999 to that in 2012?
Your answer should be very brief. 0.17. What is the ratio of the Exports(as % of merchandise exports) of Latin America(developing only) in 1999 to that in 2013?
Offer a very short reply. 0.48. What is the ratio of the Exports(as % of merchandise exports) of Benin in 1999 to that in 2013?
Offer a terse response. 280.92. What is the ratio of the Exports(as % of merchandise exports) of Greenland in 1999 to that in 2013?
Keep it short and to the point. 2.00e+04. What is the ratio of the Exports(as % of merchandise exports) in Nepal in 1999 to that in 2013?
Offer a terse response. 0.68. What is the ratio of the Exports(as % of merchandise exports) in Latin America(developing only) in 2009 to that in 2010?
Offer a terse response. 0.9. What is the ratio of the Exports(as % of merchandise exports) of Benin in 2009 to that in 2010?
Keep it short and to the point. 0.74. What is the ratio of the Exports(as % of merchandise exports) of Greenland in 2009 to that in 2010?
Your answer should be very brief. 0.13. What is the ratio of the Exports(as % of merchandise exports) in Nepal in 2009 to that in 2010?
Offer a terse response. 37.35. What is the ratio of the Exports(as % of merchandise exports) in Latin America(developing only) in 2009 to that in 2011?
Your answer should be compact. 0.81. What is the ratio of the Exports(as % of merchandise exports) in Benin in 2009 to that in 2011?
Make the answer very short. 0.08. What is the ratio of the Exports(as % of merchandise exports) of Greenland in 2009 to that in 2011?
Offer a very short reply. 0.24. What is the ratio of the Exports(as % of merchandise exports) in Nepal in 2009 to that in 2011?
Make the answer very short. 325.88. What is the ratio of the Exports(as % of merchandise exports) of Latin America(developing only) in 2009 to that in 2012?
Keep it short and to the point. 0.84. What is the ratio of the Exports(as % of merchandise exports) in Benin in 2009 to that in 2012?
Offer a terse response. 1.56. What is the ratio of the Exports(as % of merchandise exports) in Greenland in 2009 to that in 2012?
Your response must be concise. 0.48. What is the ratio of the Exports(as % of merchandise exports) in Nepal in 2009 to that in 2012?
Your answer should be very brief. 0.13. What is the ratio of the Exports(as % of merchandise exports) of Latin America(developing only) in 2009 to that in 2013?
Offer a very short reply. 0.93. What is the ratio of the Exports(as % of merchandise exports) in Benin in 2009 to that in 2013?
Make the answer very short. 3.37. What is the ratio of the Exports(as % of merchandise exports) in Greenland in 2009 to that in 2013?
Your answer should be compact. 0.85. What is the ratio of the Exports(as % of merchandise exports) in Nepal in 2009 to that in 2013?
Offer a very short reply. 0.53. What is the ratio of the Exports(as % of merchandise exports) in Latin America(developing only) in 2010 to that in 2011?
Make the answer very short. 0.9. What is the ratio of the Exports(as % of merchandise exports) in Benin in 2010 to that in 2011?
Give a very brief answer. 0.1. What is the ratio of the Exports(as % of merchandise exports) of Greenland in 2010 to that in 2011?
Make the answer very short. 1.84. What is the ratio of the Exports(as % of merchandise exports) in Nepal in 2010 to that in 2011?
Give a very brief answer. 8.73. What is the ratio of the Exports(as % of merchandise exports) of Latin America(developing only) in 2010 to that in 2012?
Offer a terse response. 0.93. What is the ratio of the Exports(as % of merchandise exports) of Benin in 2010 to that in 2012?
Make the answer very short. 2.1. What is the ratio of the Exports(as % of merchandise exports) in Greenland in 2010 to that in 2012?
Offer a very short reply. 3.76. What is the ratio of the Exports(as % of merchandise exports) in Nepal in 2010 to that in 2012?
Offer a terse response. 0. What is the ratio of the Exports(as % of merchandise exports) of Latin America(developing only) in 2010 to that in 2013?
Provide a succinct answer. 1.03. What is the ratio of the Exports(as % of merchandise exports) in Benin in 2010 to that in 2013?
Make the answer very short. 4.53. What is the ratio of the Exports(as % of merchandise exports) of Greenland in 2010 to that in 2013?
Your answer should be very brief. 6.64. What is the ratio of the Exports(as % of merchandise exports) of Nepal in 2010 to that in 2013?
Keep it short and to the point. 0.01. What is the ratio of the Exports(as % of merchandise exports) in Latin America(developing only) in 2011 to that in 2012?
Your answer should be very brief. 1.04. What is the ratio of the Exports(as % of merchandise exports) of Benin in 2011 to that in 2012?
Provide a succinct answer. 20.62. What is the ratio of the Exports(as % of merchandise exports) in Greenland in 2011 to that in 2012?
Keep it short and to the point. 2.04. What is the ratio of the Exports(as % of merchandise exports) in Latin America(developing only) in 2011 to that in 2013?
Your answer should be compact. 1.15. What is the ratio of the Exports(as % of merchandise exports) in Benin in 2011 to that in 2013?
Offer a terse response. 44.54. What is the ratio of the Exports(as % of merchandise exports) in Greenland in 2011 to that in 2013?
Your response must be concise. 3.6. What is the ratio of the Exports(as % of merchandise exports) of Nepal in 2011 to that in 2013?
Your answer should be very brief. 0. What is the ratio of the Exports(as % of merchandise exports) in Latin America(developing only) in 2012 to that in 2013?
Your response must be concise. 1.11. What is the ratio of the Exports(as % of merchandise exports) in Benin in 2012 to that in 2013?
Offer a terse response. 2.16. What is the ratio of the Exports(as % of merchandise exports) of Greenland in 2012 to that in 2013?
Your response must be concise. 1.77. What is the ratio of the Exports(as % of merchandise exports) in Nepal in 2012 to that in 2013?
Give a very brief answer. 4.02. What is the difference between the highest and the second highest Exports(as % of merchandise exports) of Latin America(developing only)?
Ensure brevity in your answer.  0.64. What is the difference between the highest and the second highest Exports(as % of merchandise exports) in Benin?
Your response must be concise. 0.56. What is the difference between the highest and the second highest Exports(as % of merchandise exports) in Greenland?
Provide a succinct answer. 1.41. What is the difference between the highest and the second highest Exports(as % of merchandise exports) of Nepal?
Your response must be concise. 0.01. What is the difference between the highest and the lowest Exports(as % of merchandise exports) in Latin America(developing only)?
Ensure brevity in your answer.  10.07. What is the difference between the highest and the lowest Exports(as % of merchandise exports) of Benin?
Provide a succinct answer. 0.66. What is the difference between the highest and the lowest Exports(as % of merchandise exports) of Greenland?
Ensure brevity in your answer.  1.41. What is the difference between the highest and the lowest Exports(as % of merchandise exports) of Nepal?
Your response must be concise. 0.01. 